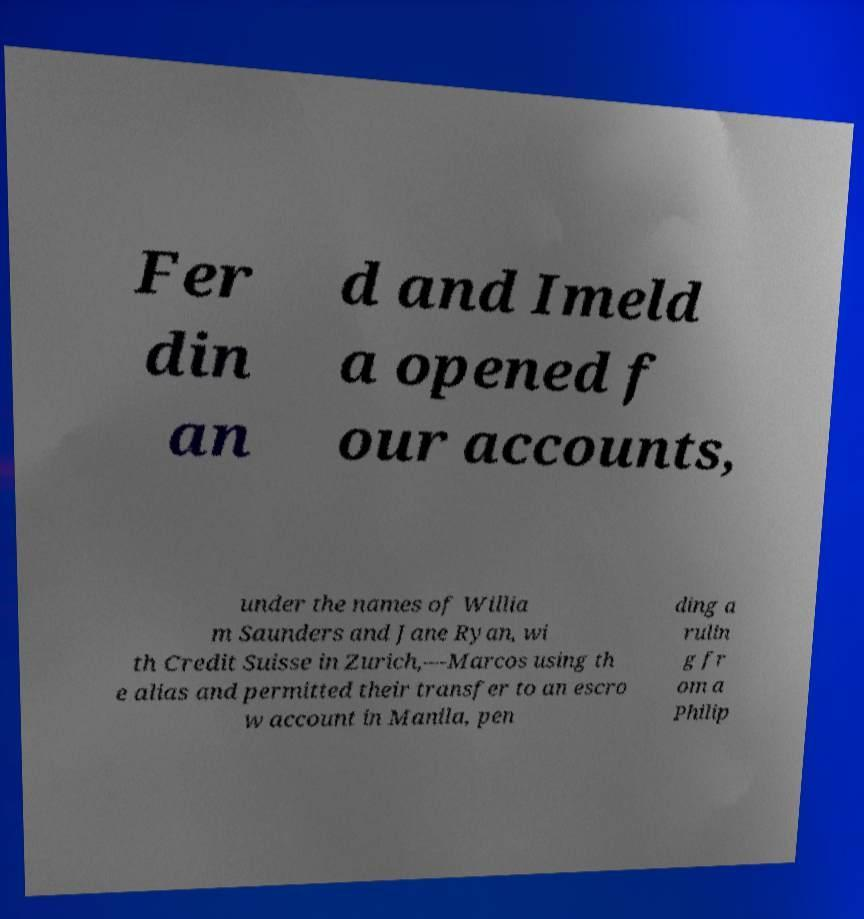For documentation purposes, I need the text within this image transcribed. Could you provide that? Fer din an d and Imeld a opened f our accounts, under the names of Willia m Saunders and Jane Ryan, wi th Credit Suisse in Zurich,—Marcos using th e alias and permitted their transfer to an escro w account in Manila, pen ding a rulin g fr om a Philip 